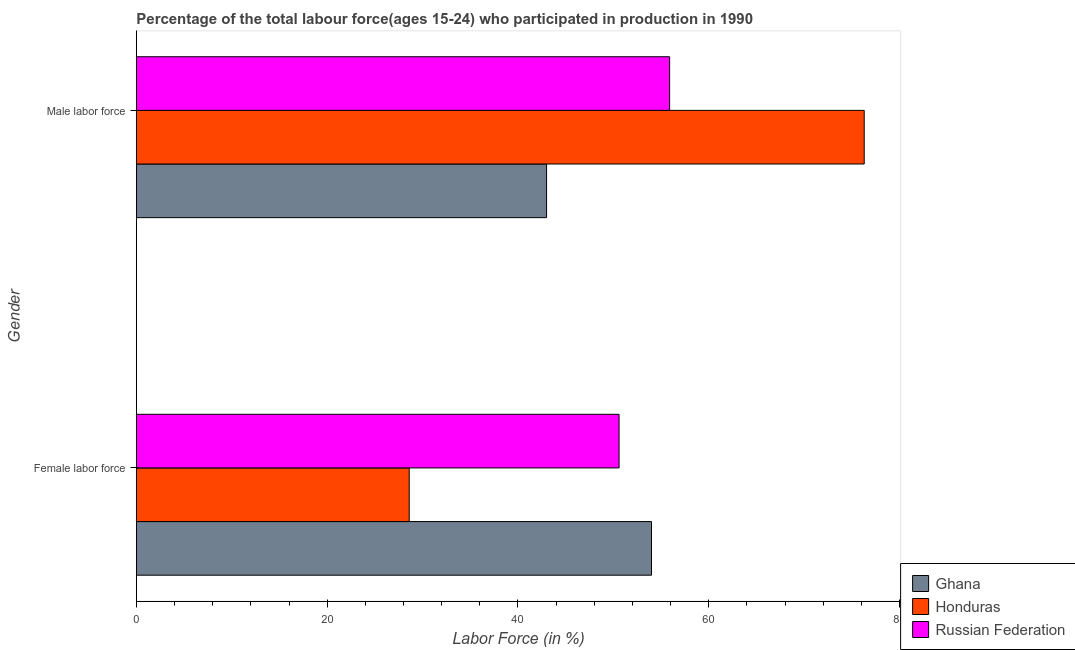Are the number of bars on each tick of the Y-axis equal?
Make the answer very short. Yes. How many bars are there on the 2nd tick from the bottom?
Offer a terse response. 3. What is the label of the 1st group of bars from the top?
Your answer should be very brief. Male labor force. What is the percentage of male labour force in Russian Federation?
Your answer should be very brief. 55.9. Across all countries, what is the minimum percentage of male labour force?
Provide a succinct answer. 43. In which country was the percentage of female labor force maximum?
Make the answer very short. Ghana. In which country was the percentage of male labour force minimum?
Give a very brief answer. Ghana. What is the total percentage of female labor force in the graph?
Keep it short and to the point. 133.2. What is the difference between the percentage of male labour force in Honduras and that in Ghana?
Give a very brief answer. 33.3. What is the difference between the percentage of female labor force in Honduras and the percentage of male labour force in Russian Federation?
Your answer should be compact. -27.3. What is the average percentage of female labor force per country?
Your answer should be very brief. 44.4. What is the difference between the percentage of female labor force and percentage of male labour force in Honduras?
Your answer should be very brief. -47.7. What is the ratio of the percentage of male labour force in Russian Federation to that in Honduras?
Your answer should be compact. 0.73. What does the 3rd bar from the bottom in Female labor force represents?
Make the answer very short. Russian Federation. How many bars are there?
Give a very brief answer. 6. How many countries are there in the graph?
Your answer should be very brief. 3. What is the difference between two consecutive major ticks on the X-axis?
Your response must be concise. 20. Are the values on the major ticks of X-axis written in scientific E-notation?
Give a very brief answer. No. Where does the legend appear in the graph?
Give a very brief answer. Bottom right. How are the legend labels stacked?
Provide a succinct answer. Vertical. What is the title of the graph?
Offer a terse response. Percentage of the total labour force(ages 15-24) who participated in production in 1990. Does "Uruguay" appear as one of the legend labels in the graph?
Your response must be concise. No. What is the label or title of the X-axis?
Offer a very short reply. Labor Force (in %). What is the Labor Force (in %) in Honduras in Female labor force?
Offer a very short reply. 28.6. What is the Labor Force (in %) in Russian Federation in Female labor force?
Keep it short and to the point. 50.6. What is the Labor Force (in %) in Honduras in Male labor force?
Make the answer very short. 76.3. What is the Labor Force (in %) in Russian Federation in Male labor force?
Your response must be concise. 55.9. Across all Gender, what is the maximum Labor Force (in %) in Ghana?
Offer a terse response. 54. Across all Gender, what is the maximum Labor Force (in %) in Honduras?
Make the answer very short. 76.3. Across all Gender, what is the maximum Labor Force (in %) in Russian Federation?
Keep it short and to the point. 55.9. Across all Gender, what is the minimum Labor Force (in %) of Honduras?
Provide a succinct answer. 28.6. Across all Gender, what is the minimum Labor Force (in %) in Russian Federation?
Keep it short and to the point. 50.6. What is the total Labor Force (in %) in Ghana in the graph?
Make the answer very short. 97. What is the total Labor Force (in %) in Honduras in the graph?
Keep it short and to the point. 104.9. What is the total Labor Force (in %) in Russian Federation in the graph?
Give a very brief answer. 106.5. What is the difference between the Labor Force (in %) of Ghana in Female labor force and that in Male labor force?
Ensure brevity in your answer.  11. What is the difference between the Labor Force (in %) of Honduras in Female labor force and that in Male labor force?
Provide a short and direct response. -47.7. What is the difference between the Labor Force (in %) of Ghana in Female labor force and the Labor Force (in %) of Honduras in Male labor force?
Provide a short and direct response. -22.3. What is the difference between the Labor Force (in %) of Honduras in Female labor force and the Labor Force (in %) of Russian Federation in Male labor force?
Offer a terse response. -27.3. What is the average Labor Force (in %) of Ghana per Gender?
Your response must be concise. 48.5. What is the average Labor Force (in %) in Honduras per Gender?
Make the answer very short. 52.45. What is the average Labor Force (in %) in Russian Federation per Gender?
Your response must be concise. 53.25. What is the difference between the Labor Force (in %) of Ghana and Labor Force (in %) of Honduras in Female labor force?
Your response must be concise. 25.4. What is the difference between the Labor Force (in %) of Ghana and Labor Force (in %) of Russian Federation in Female labor force?
Offer a terse response. 3.4. What is the difference between the Labor Force (in %) of Ghana and Labor Force (in %) of Honduras in Male labor force?
Your response must be concise. -33.3. What is the difference between the Labor Force (in %) of Ghana and Labor Force (in %) of Russian Federation in Male labor force?
Your answer should be very brief. -12.9. What is the difference between the Labor Force (in %) in Honduras and Labor Force (in %) in Russian Federation in Male labor force?
Offer a very short reply. 20.4. What is the ratio of the Labor Force (in %) in Ghana in Female labor force to that in Male labor force?
Provide a succinct answer. 1.26. What is the ratio of the Labor Force (in %) in Honduras in Female labor force to that in Male labor force?
Make the answer very short. 0.37. What is the ratio of the Labor Force (in %) of Russian Federation in Female labor force to that in Male labor force?
Give a very brief answer. 0.91. What is the difference between the highest and the second highest Labor Force (in %) of Honduras?
Your answer should be compact. 47.7. What is the difference between the highest and the lowest Labor Force (in %) of Honduras?
Give a very brief answer. 47.7. What is the difference between the highest and the lowest Labor Force (in %) of Russian Federation?
Make the answer very short. 5.3. 